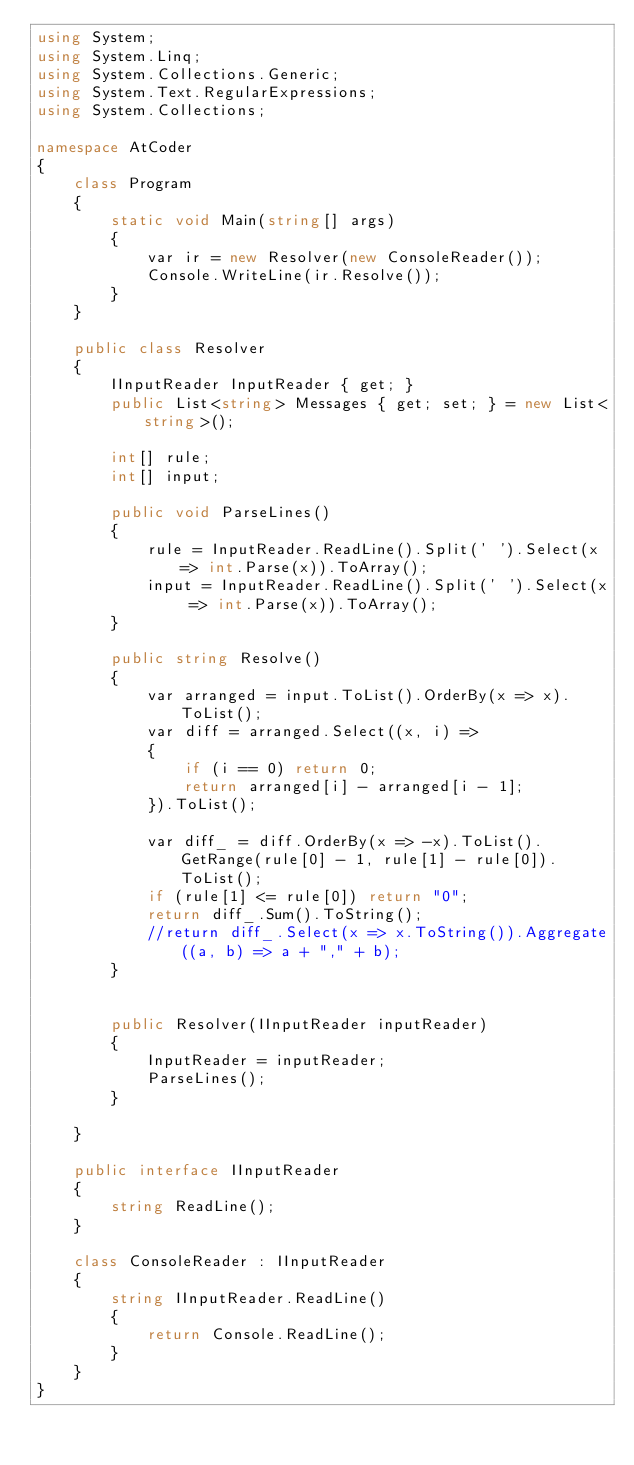Convert code to text. <code><loc_0><loc_0><loc_500><loc_500><_C#_>using System;
using System.Linq;
using System.Collections.Generic;
using System.Text.RegularExpressions;
using System.Collections;

namespace AtCoder
{
    class Program
    {
        static void Main(string[] args)
        {
            var ir = new Resolver(new ConsoleReader());
            Console.WriteLine(ir.Resolve());
        }
    }

    public class Resolver
    {
        IInputReader InputReader { get; }
        public List<string> Messages { get; set; } = new List<string>();

        int[] rule;
        int[] input;

        public void ParseLines()
        {
            rule = InputReader.ReadLine().Split(' ').Select(x => int.Parse(x)).ToArray();
            input = InputReader.ReadLine().Split(' ').Select(x => int.Parse(x)).ToArray();
        }

        public string Resolve()
        {
            var arranged = input.ToList().OrderBy(x => x).ToList();
            var diff = arranged.Select((x, i) =>
            {
                if (i == 0) return 0;
                return arranged[i] - arranged[i - 1];
            }).ToList();

            var diff_ = diff.OrderBy(x => -x).ToList().GetRange(rule[0] - 1, rule[1] - rule[0]).ToList();
            if (rule[1] <= rule[0]) return "0";
            return diff_.Sum().ToString();
            //return diff_.Select(x => x.ToString()).Aggregate((a, b) => a + "," + b);
        }


        public Resolver(IInputReader inputReader)
        {
            InputReader = inputReader;
            ParseLines();
        }

    }

    public interface IInputReader
    {
        string ReadLine();
    }

    class ConsoleReader : IInputReader
    {
        string IInputReader.ReadLine()
        {
            return Console.ReadLine();
        }
    }
}</code> 